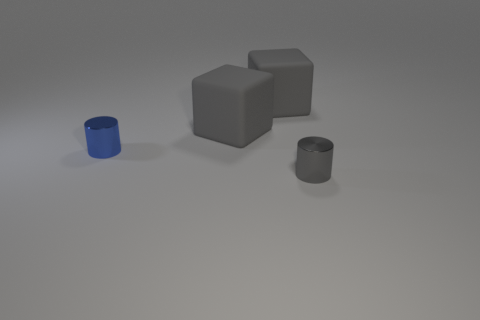Are there any tiny gray things?
Offer a terse response. Yes. There is a shiny object that is in front of the small cylinder behind the small gray metallic cylinder in front of the small blue metallic cylinder; what size is it?
Keep it short and to the point. Small. Are there any small cylinders on the right side of the tiny blue object?
Keep it short and to the point. Yes. There is a gray thing that is the same material as the tiny blue cylinder; what size is it?
Your answer should be very brief. Small. How many tiny brown metallic things have the same shape as the blue object?
Give a very brief answer. 0. Is the number of cubes on the right side of the tiny blue shiny cylinder greater than the number of small blue shiny cylinders?
Make the answer very short. Yes. Are there any small gray objects that have the same material as the tiny blue cylinder?
Your answer should be very brief. Yes. Is the material of the tiny object that is to the right of the blue cylinder the same as the tiny cylinder that is left of the small gray thing?
Offer a terse response. Yes. Are there an equal number of big gray blocks to the right of the tiny gray metal thing and large gray matte things that are to the right of the blue metal cylinder?
Ensure brevity in your answer.  No. The shiny object that is the same size as the gray metal cylinder is what color?
Ensure brevity in your answer.  Blue. 